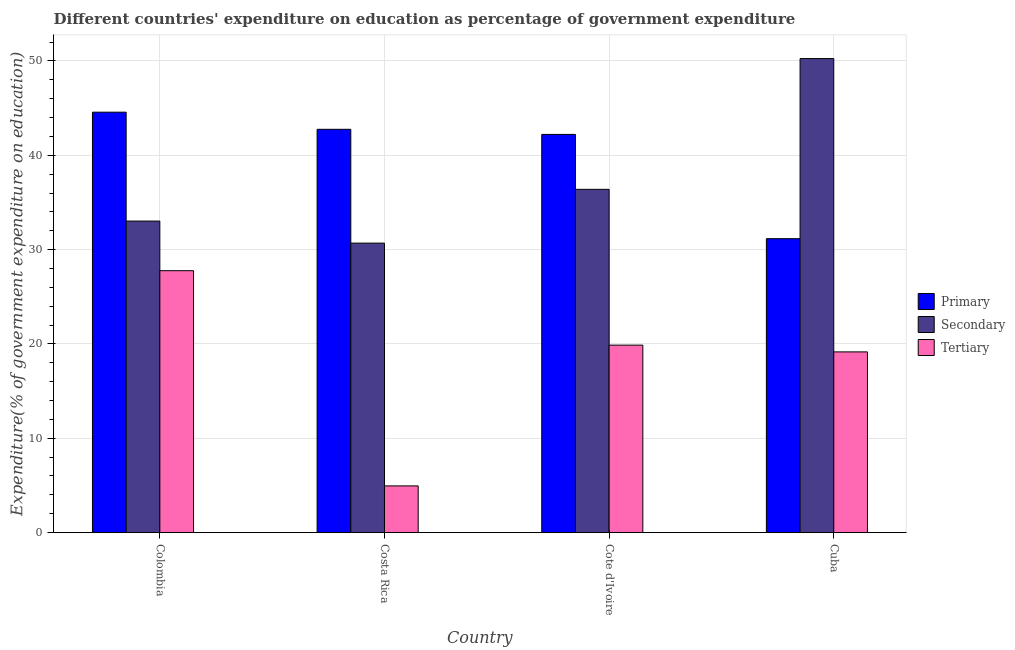How many groups of bars are there?
Offer a very short reply. 4. Are the number of bars on each tick of the X-axis equal?
Your response must be concise. Yes. What is the expenditure on secondary education in Cuba?
Provide a succinct answer. 50.25. Across all countries, what is the maximum expenditure on tertiary education?
Keep it short and to the point. 27.77. Across all countries, what is the minimum expenditure on tertiary education?
Keep it short and to the point. 4.95. In which country was the expenditure on secondary education minimum?
Make the answer very short. Costa Rica. What is the total expenditure on tertiary education in the graph?
Your answer should be very brief. 71.75. What is the difference between the expenditure on secondary education in Costa Rica and that in Cuba?
Your answer should be compact. -19.57. What is the difference between the expenditure on tertiary education in Colombia and the expenditure on secondary education in Cote d'Ivoire?
Your answer should be compact. -8.62. What is the average expenditure on primary education per country?
Provide a succinct answer. 40.18. What is the difference between the expenditure on secondary education and expenditure on tertiary education in Cote d'Ivoire?
Keep it short and to the point. 16.52. What is the ratio of the expenditure on secondary education in Colombia to that in Cote d'Ivoire?
Ensure brevity in your answer.  0.91. Is the difference between the expenditure on primary education in Colombia and Cote d'Ivoire greater than the difference between the expenditure on tertiary education in Colombia and Cote d'Ivoire?
Provide a short and direct response. No. What is the difference between the highest and the second highest expenditure on tertiary education?
Keep it short and to the point. 7.89. What is the difference between the highest and the lowest expenditure on primary education?
Provide a short and direct response. 13.41. What does the 1st bar from the left in Cuba represents?
Provide a short and direct response. Primary. What does the 1st bar from the right in Costa Rica represents?
Provide a short and direct response. Tertiary. Are all the bars in the graph horizontal?
Provide a short and direct response. No. Where does the legend appear in the graph?
Your answer should be compact. Center right. How many legend labels are there?
Your response must be concise. 3. How are the legend labels stacked?
Provide a succinct answer. Vertical. What is the title of the graph?
Your answer should be very brief. Different countries' expenditure on education as percentage of government expenditure. What is the label or title of the X-axis?
Give a very brief answer. Country. What is the label or title of the Y-axis?
Provide a succinct answer. Expenditure(% of government expenditure on education). What is the Expenditure(% of government expenditure on education) in Primary in Colombia?
Provide a short and direct response. 44.57. What is the Expenditure(% of government expenditure on education) of Secondary in Colombia?
Keep it short and to the point. 33.03. What is the Expenditure(% of government expenditure on education) of Tertiary in Colombia?
Your response must be concise. 27.77. What is the Expenditure(% of government expenditure on education) of Primary in Costa Rica?
Your response must be concise. 42.76. What is the Expenditure(% of government expenditure on education) in Secondary in Costa Rica?
Keep it short and to the point. 30.69. What is the Expenditure(% of government expenditure on education) of Tertiary in Costa Rica?
Offer a very short reply. 4.95. What is the Expenditure(% of government expenditure on education) of Primary in Cote d'Ivoire?
Your response must be concise. 42.21. What is the Expenditure(% of government expenditure on education) in Secondary in Cote d'Ivoire?
Provide a short and direct response. 36.39. What is the Expenditure(% of government expenditure on education) in Tertiary in Cote d'Ivoire?
Your answer should be very brief. 19.87. What is the Expenditure(% of government expenditure on education) of Primary in Cuba?
Provide a succinct answer. 31.16. What is the Expenditure(% of government expenditure on education) of Secondary in Cuba?
Ensure brevity in your answer.  50.25. What is the Expenditure(% of government expenditure on education) of Tertiary in Cuba?
Ensure brevity in your answer.  19.16. Across all countries, what is the maximum Expenditure(% of government expenditure on education) in Primary?
Your answer should be very brief. 44.57. Across all countries, what is the maximum Expenditure(% of government expenditure on education) in Secondary?
Your response must be concise. 50.25. Across all countries, what is the maximum Expenditure(% of government expenditure on education) of Tertiary?
Keep it short and to the point. 27.77. Across all countries, what is the minimum Expenditure(% of government expenditure on education) of Primary?
Your answer should be compact. 31.16. Across all countries, what is the minimum Expenditure(% of government expenditure on education) of Secondary?
Your answer should be compact. 30.69. Across all countries, what is the minimum Expenditure(% of government expenditure on education) of Tertiary?
Your response must be concise. 4.95. What is the total Expenditure(% of government expenditure on education) in Primary in the graph?
Your response must be concise. 160.7. What is the total Expenditure(% of government expenditure on education) of Secondary in the graph?
Your response must be concise. 150.36. What is the total Expenditure(% of government expenditure on education) in Tertiary in the graph?
Your response must be concise. 71.75. What is the difference between the Expenditure(% of government expenditure on education) in Primary in Colombia and that in Costa Rica?
Provide a short and direct response. 1.82. What is the difference between the Expenditure(% of government expenditure on education) in Secondary in Colombia and that in Costa Rica?
Give a very brief answer. 2.34. What is the difference between the Expenditure(% of government expenditure on education) of Tertiary in Colombia and that in Costa Rica?
Make the answer very short. 22.82. What is the difference between the Expenditure(% of government expenditure on education) of Primary in Colombia and that in Cote d'Ivoire?
Your response must be concise. 2.36. What is the difference between the Expenditure(% of government expenditure on education) of Secondary in Colombia and that in Cote d'Ivoire?
Your response must be concise. -3.36. What is the difference between the Expenditure(% of government expenditure on education) of Tertiary in Colombia and that in Cote d'Ivoire?
Provide a short and direct response. 7.89. What is the difference between the Expenditure(% of government expenditure on education) of Primary in Colombia and that in Cuba?
Provide a succinct answer. 13.41. What is the difference between the Expenditure(% of government expenditure on education) in Secondary in Colombia and that in Cuba?
Ensure brevity in your answer.  -17.23. What is the difference between the Expenditure(% of government expenditure on education) in Tertiary in Colombia and that in Cuba?
Offer a terse response. 8.61. What is the difference between the Expenditure(% of government expenditure on education) in Primary in Costa Rica and that in Cote d'Ivoire?
Ensure brevity in your answer.  0.54. What is the difference between the Expenditure(% of government expenditure on education) in Secondary in Costa Rica and that in Cote d'Ivoire?
Your response must be concise. -5.7. What is the difference between the Expenditure(% of government expenditure on education) of Tertiary in Costa Rica and that in Cote d'Ivoire?
Keep it short and to the point. -14.92. What is the difference between the Expenditure(% of government expenditure on education) in Primary in Costa Rica and that in Cuba?
Provide a short and direct response. 11.6. What is the difference between the Expenditure(% of government expenditure on education) in Secondary in Costa Rica and that in Cuba?
Your answer should be very brief. -19.57. What is the difference between the Expenditure(% of government expenditure on education) of Tertiary in Costa Rica and that in Cuba?
Give a very brief answer. -14.21. What is the difference between the Expenditure(% of government expenditure on education) of Primary in Cote d'Ivoire and that in Cuba?
Provide a short and direct response. 11.05. What is the difference between the Expenditure(% of government expenditure on education) of Secondary in Cote d'Ivoire and that in Cuba?
Give a very brief answer. -13.86. What is the difference between the Expenditure(% of government expenditure on education) in Tertiary in Cote d'Ivoire and that in Cuba?
Ensure brevity in your answer.  0.72. What is the difference between the Expenditure(% of government expenditure on education) of Primary in Colombia and the Expenditure(% of government expenditure on education) of Secondary in Costa Rica?
Ensure brevity in your answer.  13.88. What is the difference between the Expenditure(% of government expenditure on education) in Primary in Colombia and the Expenditure(% of government expenditure on education) in Tertiary in Costa Rica?
Offer a very short reply. 39.62. What is the difference between the Expenditure(% of government expenditure on education) of Secondary in Colombia and the Expenditure(% of government expenditure on education) of Tertiary in Costa Rica?
Your response must be concise. 28.08. What is the difference between the Expenditure(% of government expenditure on education) in Primary in Colombia and the Expenditure(% of government expenditure on education) in Secondary in Cote d'Ivoire?
Offer a very short reply. 8.18. What is the difference between the Expenditure(% of government expenditure on education) in Primary in Colombia and the Expenditure(% of government expenditure on education) in Tertiary in Cote d'Ivoire?
Provide a succinct answer. 24.7. What is the difference between the Expenditure(% of government expenditure on education) in Secondary in Colombia and the Expenditure(% of government expenditure on education) in Tertiary in Cote d'Ivoire?
Make the answer very short. 13.15. What is the difference between the Expenditure(% of government expenditure on education) of Primary in Colombia and the Expenditure(% of government expenditure on education) of Secondary in Cuba?
Ensure brevity in your answer.  -5.68. What is the difference between the Expenditure(% of government expenditure on education) of Primary in Colombia and the Expenditure(% of government expenditure on education) of Tertiary in Cuba?
Provide a short and direct response. 25.42. What is the difference between the Expenditure(% of government expenditure on education) of Secondary in Colombia and the Expenditure(% of government expenditure on education) of Tertiary in Cuba?
Provide a succinct answer. 13.87. What is the difference between the Expenditure(% of government expenditure on education) of Primary in Costa Rica and the Expenditure(% of government expenditure on education) of Secondary in Cote d'Ivoire?
Offer a very short reply. 6.37. What is the difference between the Expenditure(% of government expenditure on education) of Primary in Costa Rica and the Expenditure(% of government expenditure on education) of Tertiary in Cote d'Ivoire?
Provide a short and direct response. 22.88. What is the difference between the Expenditure(% of government expenditure on education) in Secondary in Costa Rica and the Expenditure(% of government expenditure on education) in Tertiary in Cote d'Ivoire?
Your answer should be very brief. 10.81. What is the difference between the Expenditure(% of government expenditure on education) of Primary in Costa Rica and the Expenditure(% of government expenditure on education) of Secondary in Cuba?
Your response must be concise. -7.5. What is the difference between the Expenditure(% of government expenditure on education) of Primary in Costa Rica and the Expenditure(% of government expenditure on education) of Tertiary in Cuba?
Offer a very short reply. 23.6. What is the difference between the Expenditure(% of government expenditure on education) of Secondary in Costa Rica and the Expenditure(% of government expenditure on education) of Tertiary in Cuba?
Make the answer very short. 11.53. What is the difference between the Expenditure(% of government expenditure on education) of Primary in Cote d'Ivoire and the Expenditure(% of government expenditure on education) of Secondary in Cuba?
Provide a short and direct response. -8.04. What is the difference between the Expenditure(% of government expenditure on education) in Primary in Cote d'Ivoire and the Expenditure(% of government expenditure on education) in Tertiary in Cuba?
Make the answer very short. 23.06. What is the difference between the Expenditure(% of government expenditure on education) in Secondary in Cote d'Ivoire and the Expenditure(% of government expenditure on education) in Tertiary in Cuba?
Provide a short and direct response. 17.23. What is the average Expenditure(% of government expenditure on education) of Primary per country?
Keep it short and to the point. 40.18. What is the average Expenditure(% of government expenditure on education) of Secondary per country?
Provide a succinct answer. 37.59. What is the average Expenditure(% of government expenditure on education) of Tertiary per country?
Keep it short and to the point. 17.94. What is the difference between the Expenditure(% of government expenditure on education) in Primary and Expenditure(% of government expenditure on education) in Secondary in Colombia?
Make the answer very short. 11.54. What is the difference between the Expenditure(% of government expenditure on education) of Primary and Expenditure(% of government expenditure on education) of Tertiary in Colombia?
Provide a short and direct response. 16.81. What is the difference between the Expenditure(% of government expenditure on education) of Secondary and Expenditure(% of government expenditure on education) of Tertiary in Colombia?
Provide a succinct answer. 5.26. What is the difference between the Expenditure(% of government expenditure on education) of Primary and Expenditure(% of government expenditure on education) of Secondary in Costa Rica?
Keep it short and to the point. 12.07. What is the difference between the Expenditure(% of government expenditure on education) of Primary and Expenditure(% of government expenditure on education) of Tertiary in Costa Rica?
Keep it short and to the point. 37.81. What is the difference between the Expenditure(% of government expenditure on education) in Secondary and Expenditure(% of government expenditure on education) in Tertiary in Costa Rica?
Offer a very short reply. 25.74. What is the difference between the Expenditure(% of government expenditure on education) of Primary and Expenditure(% of government expenditure on education) of Secondary in Cote d'Ivoire?
Keep it short and to the point. 5.82. What is the difference between the Expenditure(% of government expenditure on education) in Primary and Expenditure(% of government expenditure on education) in Tertiary in Cote d'Ivoire?
Offer a terse response. 22.34. What is the difference between the Expenditure(% of government expenditure on education) in Secondary and Expenditure(% of government expenditure on education) in Tertiary in Cote d'Ivoire?
Your response must be concise. 16.52. What is the difference between the Expenditure(% of government expenditure on education) of Primary and Expenditure(% of government expenditure on education) of Secondary in Cuba?
Offer a very short reply. -19.09. What is the difference between the Expenditure(% of government expenditure on education) of Primary and Expenditure(% of government expenditure on education) of Tertiary in Cuba?
Your answer should be very brief. 12. What is the difference between the Expenditure(% of government expenditure on education) of Secondary and Expenditure(% of government expenditure on education) of Tertiary in Cuba?
Keep it short and to the point. 31.1. What is the ratio of the Expenditure(% of government expenditure on education) of Primary in Colombia to that in Costa Rica?
Your answer should be very brief. 1.04. What is the ratio of the Expenditure(% of government expenditure on education) of Secondary in Colombia to that in Costa Rica?
Offer a very short reply. 1.08. What is the ratio of the Expenditure(% of government expenditure on education) of Tertiary in Colombia to that in Costa Rica?
Offer a very short reply. 5.61. What is the ratio of the Expenditure(% of government expenditure on education) in Primary in Colombia to that in Cote d'Ivoire?
Your answer should be very brief. 1.06. What is the ratio of the Expenditure(% of government expenditure on education) in Secondary in Colombia to that in Cote d'Ivoire?
Your answer should be compact. 0.91. What is the ratio of the Expenditure(% of government expenditure on education) of Tertiary in Colombia to that in Cote d'Ivoire?
Make the answer very short. 1.4. What is the ratio of the Expenditure(% of government expenditure on education) in Primary in Colombia to that in Cuba?
Provide a short and direct response. 1.43. What is the ratio of the Expenditure(% of government expenditure on education) in Secondary in Colombia to that in Cuba?
Give a very brief answer. 0.66. What is the ratio of the Expenditure(% of government expenditure on education) of Tertiary in Colombia to that in Cuba?
Your answer should be compact. 1.45. What is the ratio of the Expenditure(% of government expenditure on education) in Primary in Costa Rica to that in Cote d'Ivoire?
Provide a short and direct response. 1.01. What is the ratio of the Expenditure(% of government expenditure on education) of Secondary in Costa Rica to that in Cote d'Ivoire?
Keep it short and to the point. 0.84. What is the ratio of the Expenditure(% of government expenditure on education) of Tertiary in Costa Rica to that in Cote d'Ivoire?
Make the answer very short. 0.25. What is the ratio of the Expenditure(% of government expenditure on education) in Primary in Costa Rica to that in Cuba?
Provide a short and direct response. 1.37. What is the ratio of the Expenditure(% of government expenditure on education) in Secondary in Costa Rica to that in Cuba?
Your response must be concise. 0.61. What is the ratio of the Expenditure(% of government expenditure on education) of Tertiary in Costa Rica to that in Cuba?
Provide a short and direct response. 0.26. What is the ratio of the Expenditure(% of government expenditure on education) of Primary in Cote d'Ivoire to that in Cuba?
Offer a very short reply. 1.35. What is the ratio of the Expenditure(% of government expenditure on education) in Secondary in Cote d'Ivoire to that in Cuba?
Offer a very short reply. 0.72. What is the ratio of the Expenditure(% of government expenditure on education) of Tertiary in Cote d'Ivoire to that in Cuba?
Provide a short and direct response. 1.04. What is the difference between the highest and the second highest Expenditure(% of government expenditure on education) in Primary?
Make the answer very short. 1.82. What is the difference between the highest and the second highest Expenditure(% of government expenditure on education) in Secondary?
Give a very brief answer. 13.86. What is the difference between the highest and the second highest Expenditure(% of government expenditure on education) of Tertiary?
Offer a very short reply. 7.89. What is the difference between the highest and the lowest Expenditure(% of government expenditure on education) of Primary?
Keep it short and to the point. 13.41. What is the difference between the highest and the lowest Expenditure(% of government expenditure on education) in Secondary?
Offer a very short reply. 19.57. What is the difference between the highest and the lowest Expenditure(% of government expenditure on education) in Tertiary?
Provide a short and direct response. 22.82. 